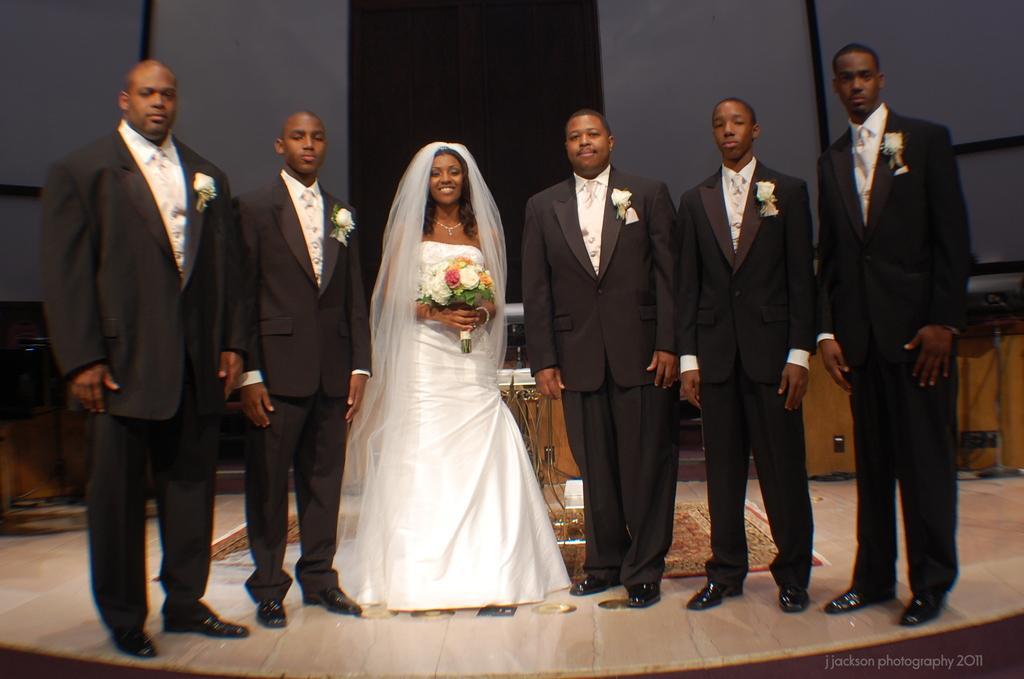In one or two sentences, can you explain what this image depicts? In this image I can see five men wearing white and black colored dresses and a woman wearing white colored dress are standing. I can see the woman is holding a flower bouquet. I can see few wooden tables and the black and grey colored background. 